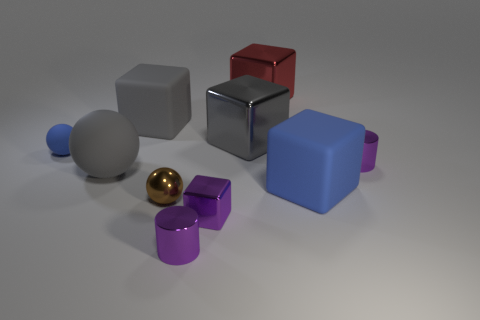Subtract all red balls. How many gray blocks are left? 2 Subtract 3 blocks. How many blocks are left? 2 Subtract all red blocks. How many blocks are left? 4 Subtract all big gray matte cubes. How many cubes are left? 4 Subtract all cyan cubes. Subtract all purple cylinders. How many cubes are left? 5 Subtract all cylinders. How many objects are left? 8 Add 2 red shiny objects. How many red shiny objects exist? 3 Subtract 0 brown cubes. How many objects are left? 10 Subtract all big gray rubber objects. Subtract all tiny matte balls. How many objects are left? 7 Add 1 matte objects. How many matte objects are left? 5 